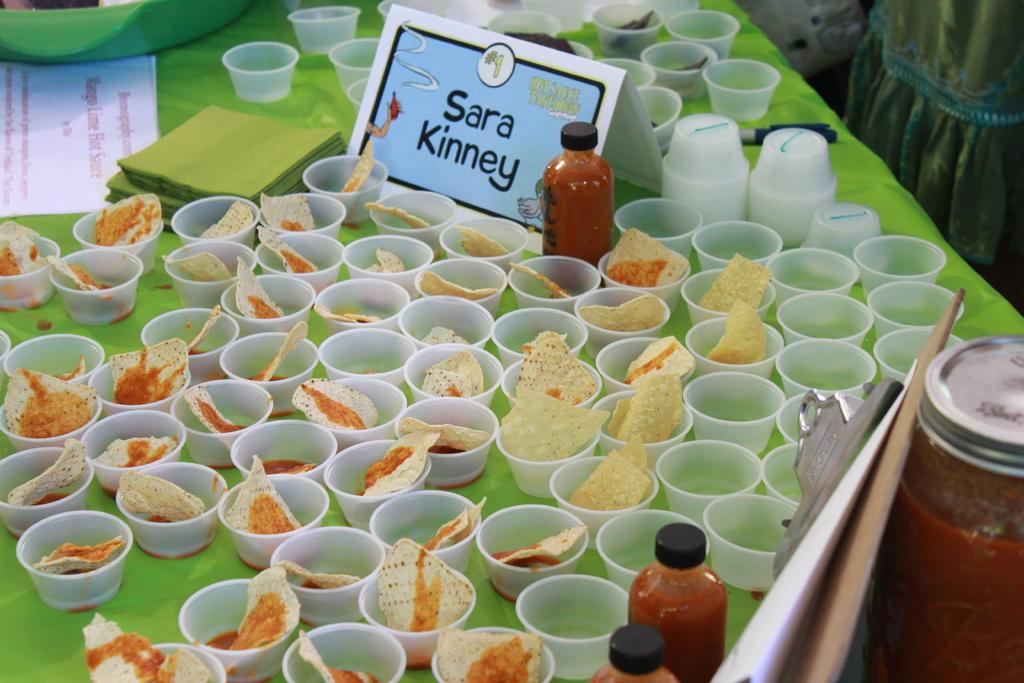What is the main piece of furniture in the image? There is a table in the image. What is covering the table? The table has a green cloth on it. What can be found on the table in terms of containers? There are many cups on the table, and they contain food items. Are there any other items on the table besides cups? Yes, there are bottles on the table. What might be used for identification purposes on the table? There is a name plate on the table. What else can be found on the table? There are papers on the table. How many team members are visible in the image? There is no team or team members present in the image. What type of wound can be seen on the table in the image? There is no wound present in the image; it is a table with various items on it. 